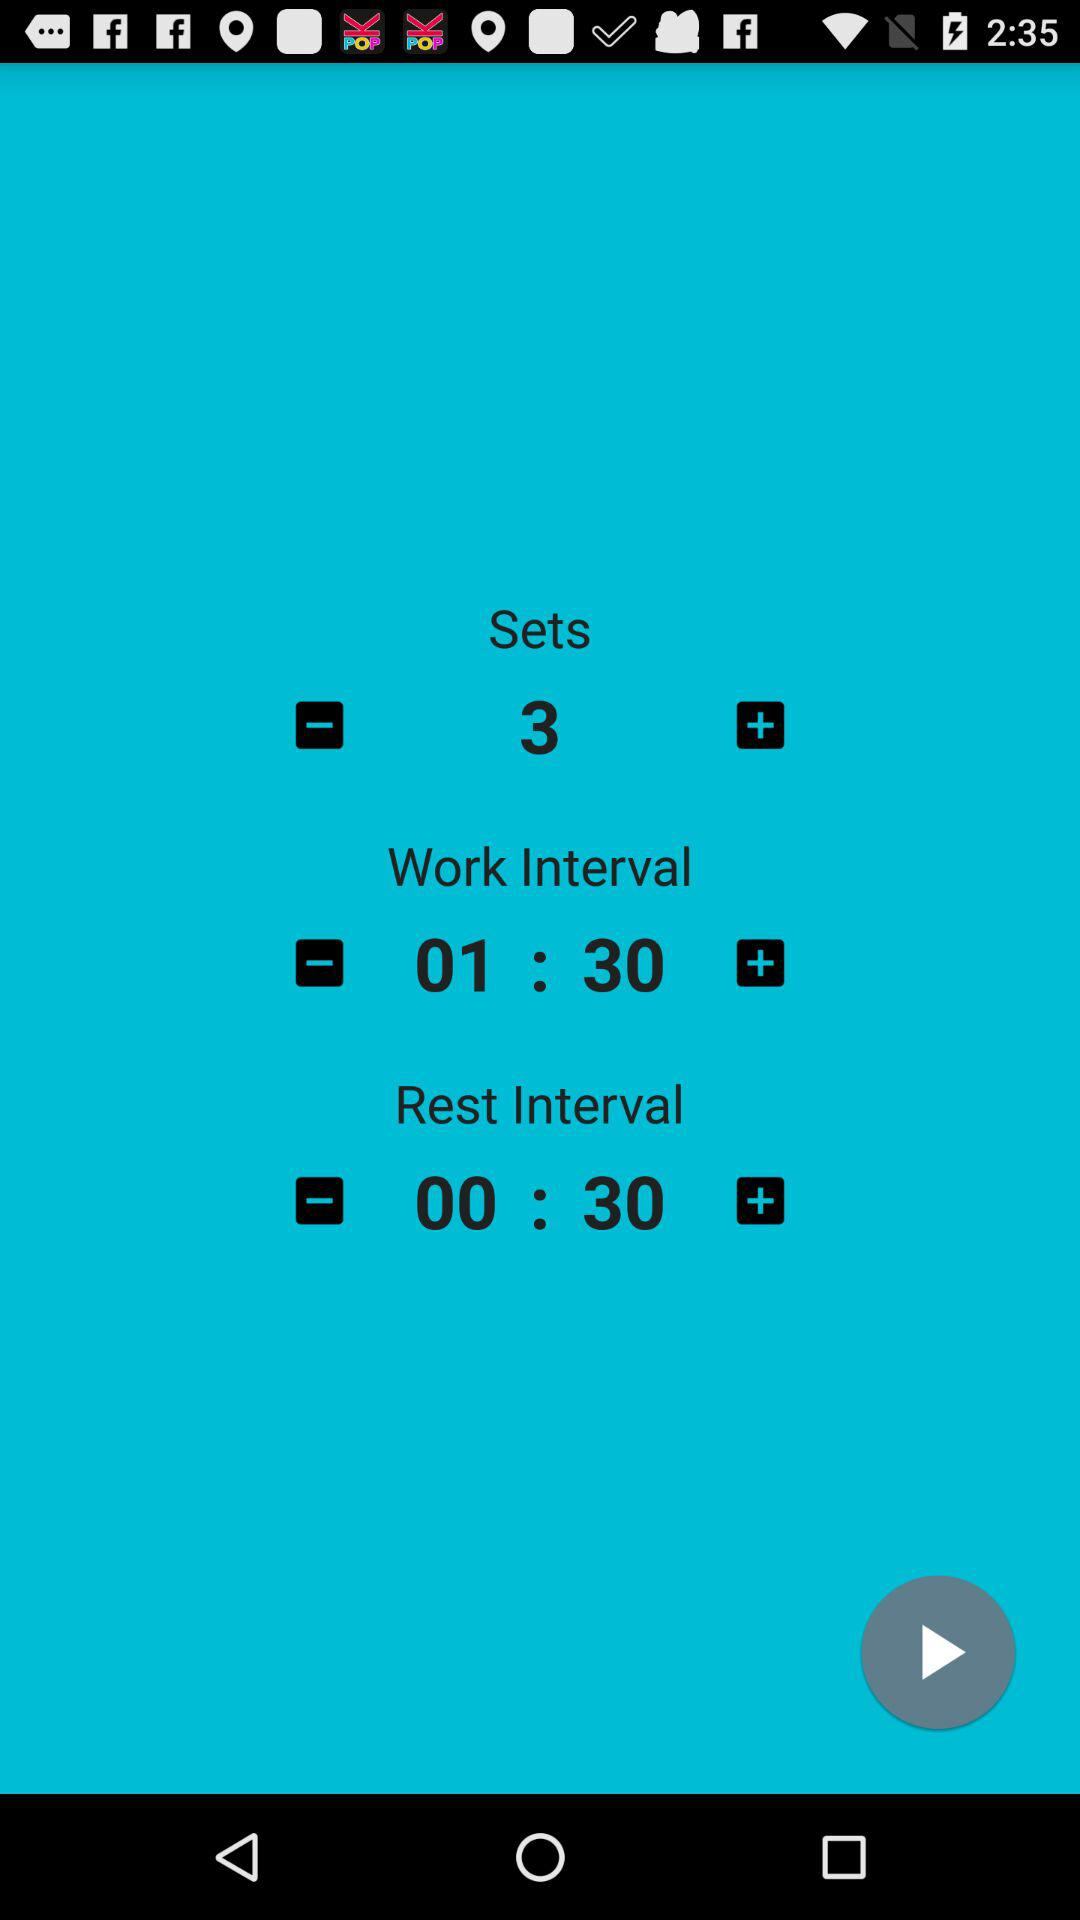How many sets are there? There are 3 sets. 